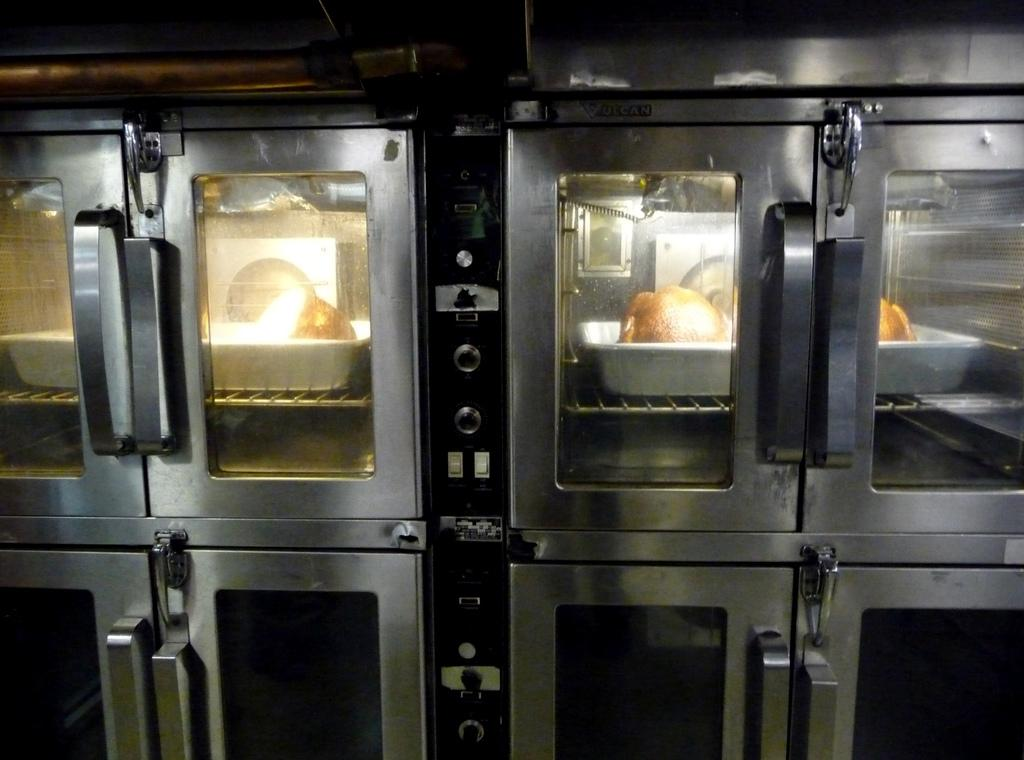What type of appliances can be seen in the image? There are ovens in the image. What is the glass used for in the image? The glass is used to view food in trays. What can be seen through the glass? Food in trays is visible through the glass. How many cakes are being copied on the page in the image? There are no cakes or pages present in the image. 